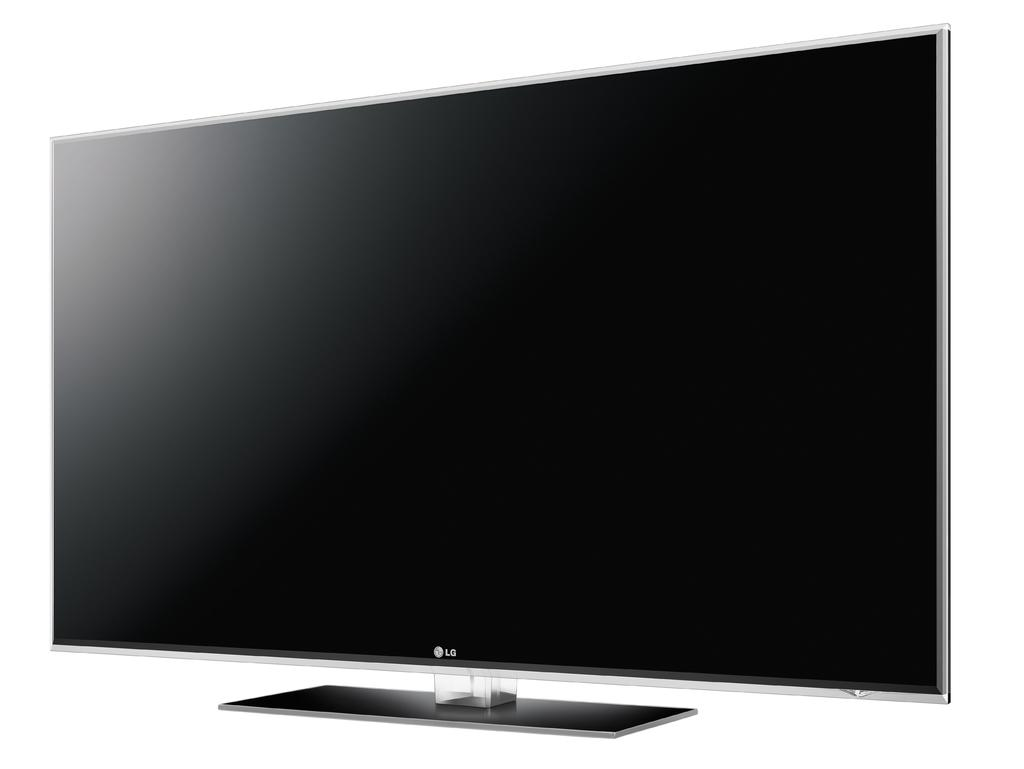<image>
Give a short and clear explanation of the subsequent image. The television shown is made by the company LG. 